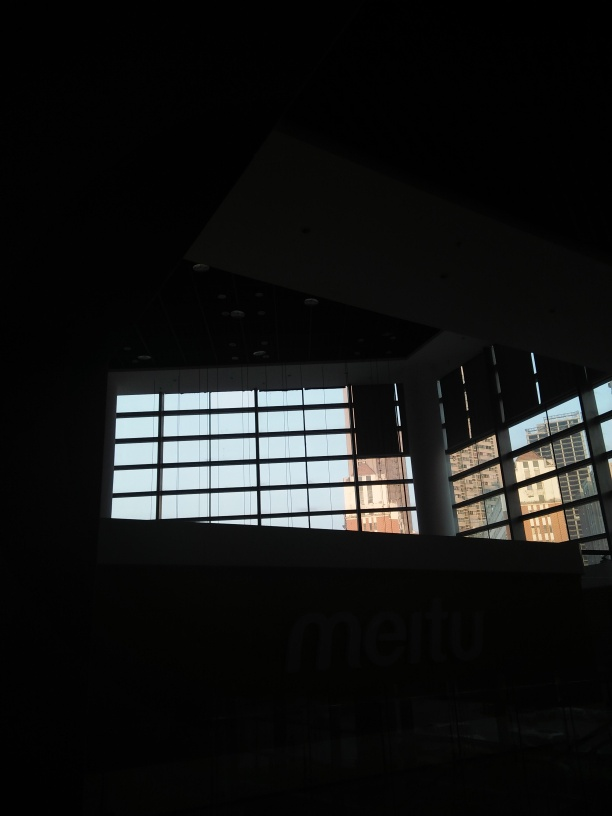What time of day does this photo seem to be taken? The photo appears to be taken during either dawn or dusk, as evidenced by the soft ambient light permeating through the large windows, casting a cool hue. This suggests it's early morning or late evening when sunlight is not at its peak. 